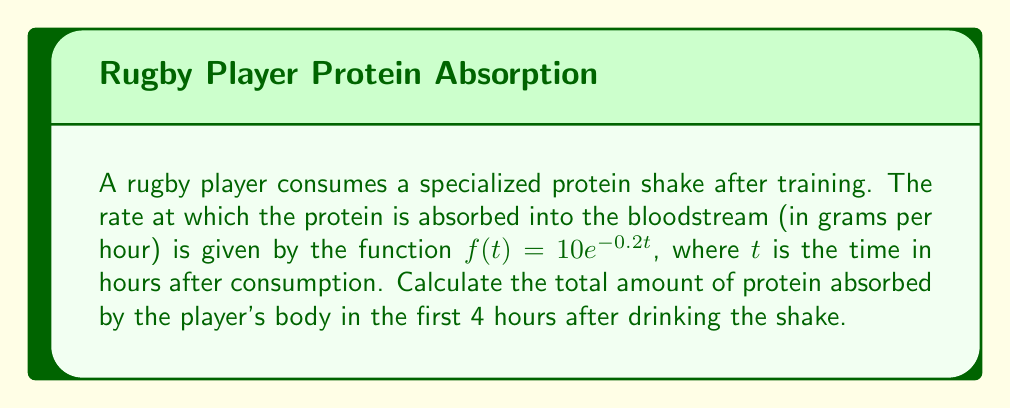Solve this math problem. To solve this problem, we need to use integral calculus to find the total amount of protein absorbed over time. The steps are as follows:

1) The rate of protein absorption is given by $f(t) = 10e^{-0.2t}$ grams/hour.

2) To find the total amount absorbed, we need to integrate this function from $t=0$ to $t=4$:

   $$\int_0^4 10e^{-0.2t} dt$$

3) Let's solve this integral:
   
   $$\int_0^4 10e^{-0.2t} dt = -50e^{-0.2t} \Big|_0^4$$

4) Evaluate the integral:
   
   $$= -50e^{-0.2(4)} - (-50e^{-0.2(0)})$$
   $$= -50e^{-0.8} + 50$$

5) Calculate the result:
   
   $$= -50(0.4493) + 50$$
   $$= -22.465 + 50$$
   $$= 27.535$$

Therefore, the total amount of protein absorbed in the first 4 hours is approximately 27.535 grams.
Answer: 27.535 grams 